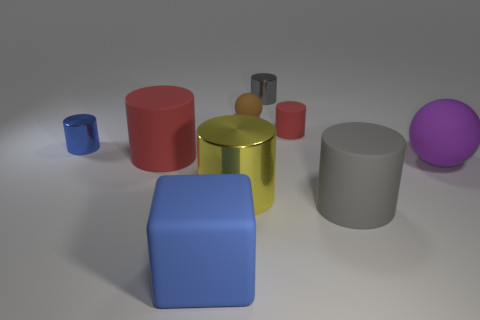Do the objects share a common material or texture? The objects appear to have different materials or finishes, with some looking matte, others shiny; however, they all share a smooth texture without visible patterns or granularity. 